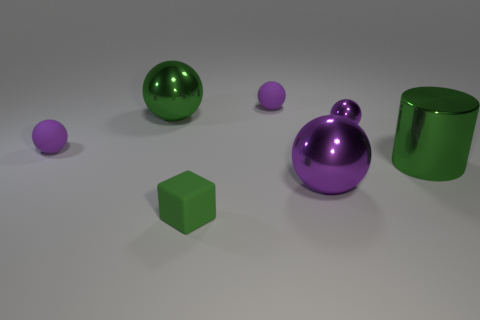Do the metallic cylinder behind the green rubber block and the green rubber thing on the left side of the small metallic thing have the same size?
Provide a short and direct response. No. There is a green metal cylinder; does it have the same size as the purple ball that is on the left side of the matte block?
Provide a succinct answer. No. How many cylinders are green metallic objects or green objects?
Provide a short and direct response. 1. What material is the large green object right of the ball in front of the green metal thing in front of the tiny metallic ball made of?
Your answer should be compact. Metal. How many other things are the same size as the block?
Provide a short and direct response. 3. There is a block that is the same color as the metal cylinder; what size is it?
Keep it short and to the point. Small. Are there more large balls that are to the right of the green cube than tiny cylinders?
Offer a very short reply. Yes. Is there a small metal ball of the same color as the tiny block?
Offer a terse response. No. There is a metallic object that is the same size as the green cube; what is its color?
Give a very brief answer. Purple. There is a tiny thing in front of the shiny cylinder; how many tiny purple spheres are on the right side of it?
Offer a terse response. 2. 